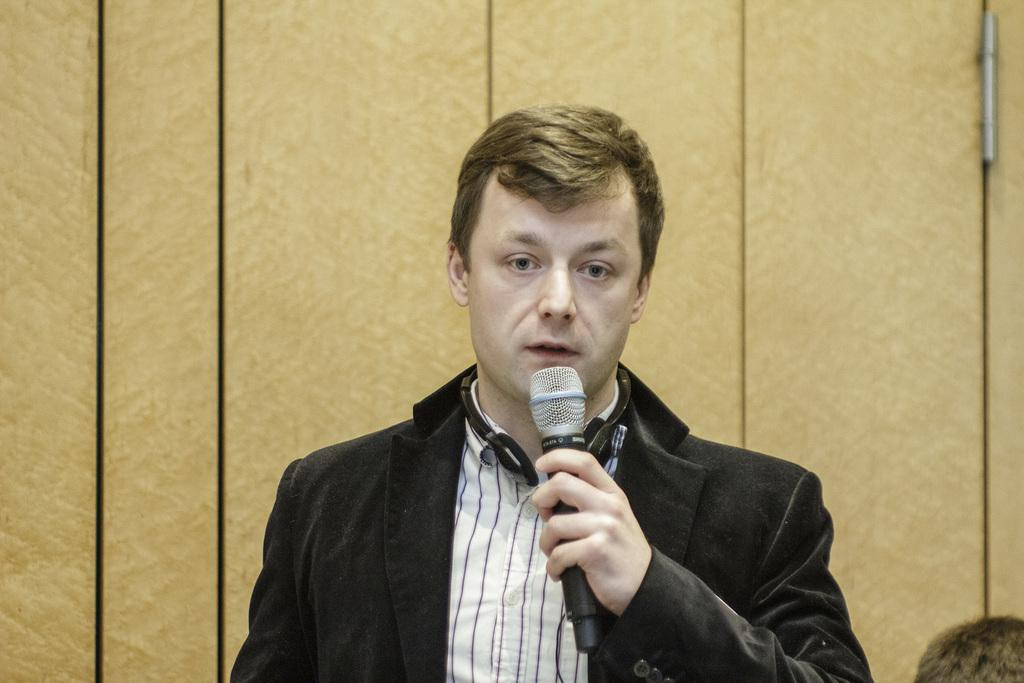Who is the main subject in the image? There is a man in the image. What is the man holding in the image? The man is holding a microphone. What is the man wearing in the image? The man is wearing a black suit. What can be seen in the background of the image? There is a door in the background of the picture. How many mice are visible in the image? There are no mice present in the image. What type of wire is connected to the microphone in the image? There is no wire connected to the microphone in the image. 